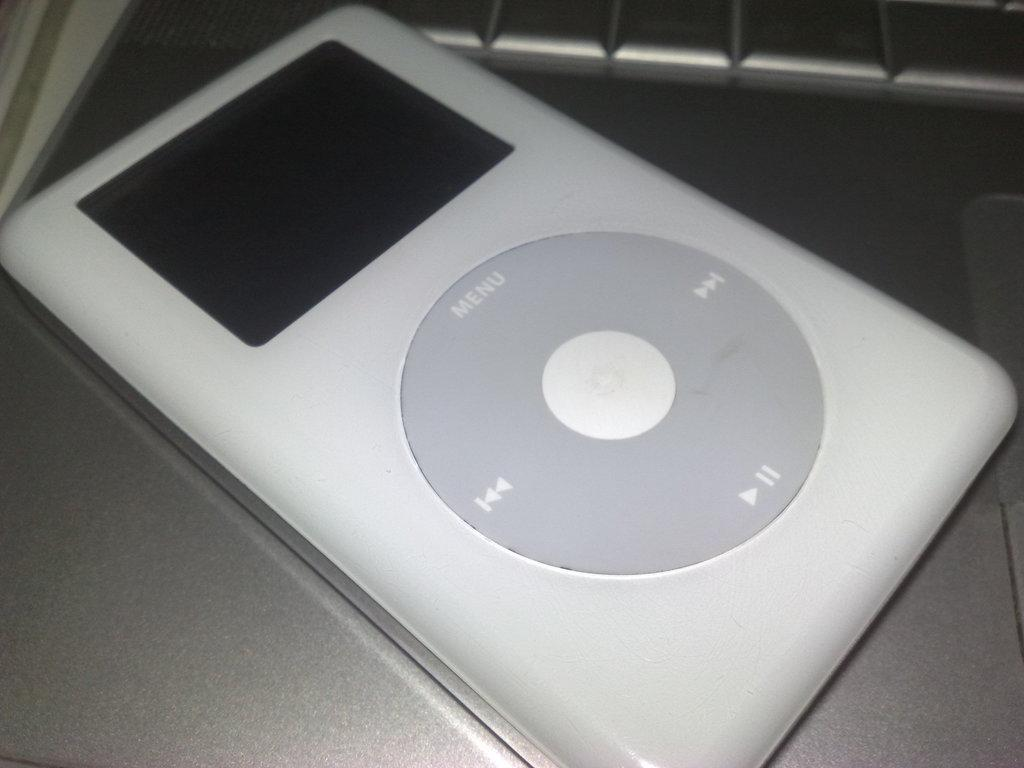What electronic device is visible in the image? There is an iPod in the image. What features does the iPod have? The iPod has buttons and a screen. What color is the iPod? The iPod is white in color. What material might the iPod be made of? The iPod may be made of metal. What type of yak can be seen using the iPod in the image? There is no yak present in the image, and therefore no such activity can be observed. What language is the iPod displaying on its screen? The image does not show the language displayed on the iPod's screen, so it cannot be determined from the image. 